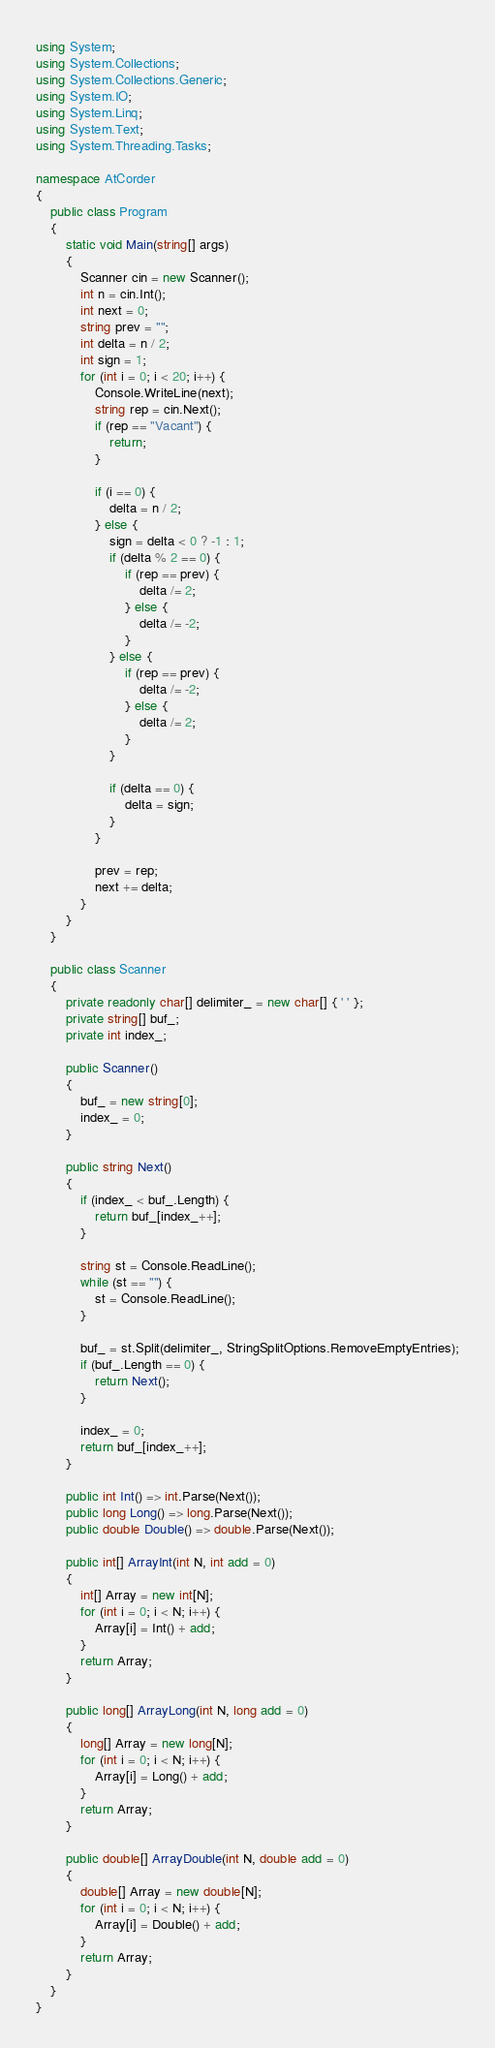<code> <loc_0><loc_0><loc_500><loc_500><_C#_>using System;
using System.Collections;
using System.Collections.Generic;
using System.IO;
using System.Linq;
using System.Text;
using System.Threading.Tasks;

namespace AtCorder
{
	public class Program
	{
		static void Main(string[] args)
		{
			Scanner cin = new Scanner();
			int n = cin.Int();
			int next = 0;
			string prev = "";
			int delta = n / 2;
			int sign = 1;
			for (int i = 0; i < 20; i++) {
				Console.WriteLine(next);
				string rep = cin.Next();
				if (rep == "Vacant") {
					return;
				}

				if (i == 0) {
					delta = n / 2;
				} else {
					sign = delta < 0 ? -1 : 1;
					if (delta % 2 == 0) {
						if (rep == prev) {
							delta /= 2;
						} else {
							delta /= -2;
						}
					} else {
						if (rep == prev) {
							delta /= -2;
						} else {
							delta /= 2;
						}
					}

					if (delta == 0) {
						delta = sign;
					}
				}

				prev = rep;
				next += delta;
			}
		}
	}

	public class Scanner
	{
		private readonly char[] delimiter_ = new char[] { ' ' };
		private string[] buf_;
		private int index_;

		public Scanner()
		{
			buf_ = new string[0];
			index_ = 0;
		}

		public string Next()
		{
			if (index_ < buf_.Length) {
				return buf_[index_++];
			}

			string st = Console.ReadLine();
			while (st == "") {
				st = Console.ReadLine();
			}

			buf_ = st.Split(delimiter_, StringSplitOptions.RemoveEmptyEntries);
			if (buf_.Length == 0) {
				return Next();
			}

			index_ = 0;
			return buf_[index_++];
		}

		public int Int() => int.Parse(Next());
		public long Long() => long.Parse(Next());
		public double Double() => double.Parse(Next());

		public int[] ArrayInt(int N, int add = 0)
		{
			int[] Array = new int[N];
			for (int i = 0; i < N; i++) {
				Array[i] = Int() + add;
			}
			return Array;
		}

		public long[] ArrayLong(int N, long add = 0)
		{
			long[] Array = new long[N];
			for (int i = 0; i < N; i++) {
				Array[i] = Long() + add;
			}
			return Array;
		}

		public double[] ArrayDouble(int N, double add = 0)
		{
			double[] Array = new double[N];
			for (int i = 0; i < N; i++) {
				Array[i] = Double() + add;
			}
			return Array;
		}
	}
}</code> 